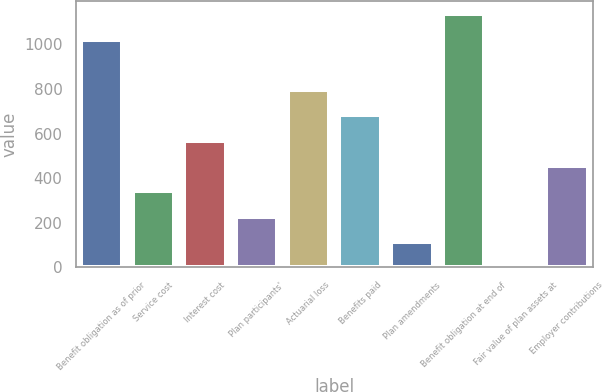Convert chart. <chart><loc_0><loc_0><loc_500><loc_500><bar_chart><fcel>Benefit obligation as of prior<fcel>Service cost<fcel>Interest cost<fcel>Plan participants'<fcel>Actuarial loss<fcel>Benefits paid<fcel>Plan amendments<fcel>Benefit obligation at end of<fcel>Fair value of plan assets at<fcel>Employer contributions<nl><fcel>1019<fcel>341.5<fcel>568.5<fcel>228<fcel>795.5<fcel>682<fcel>114.5<fcel>1136<fcel>1<fcel>455<nl></chart> 